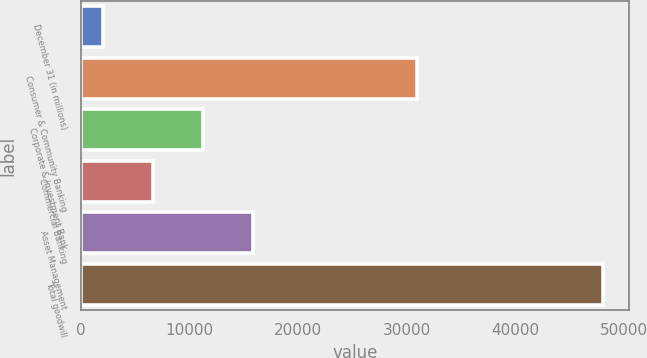<chart> <loc_0><loc_0><loc_500><loc_500><bar_chart><fcel>December 31 (in millions)<fcel>Consumer & Community Banking<fcel>Corporate & Investment Bank<fcel>Commercial Banking<fcel>Asset Management<fcel>Total goodwill<nl><fcel>2013<fcel>30985<fcel>11226.6<fcel>6619.8<fcel>15833.4<fcel>48081<nl></chart> 